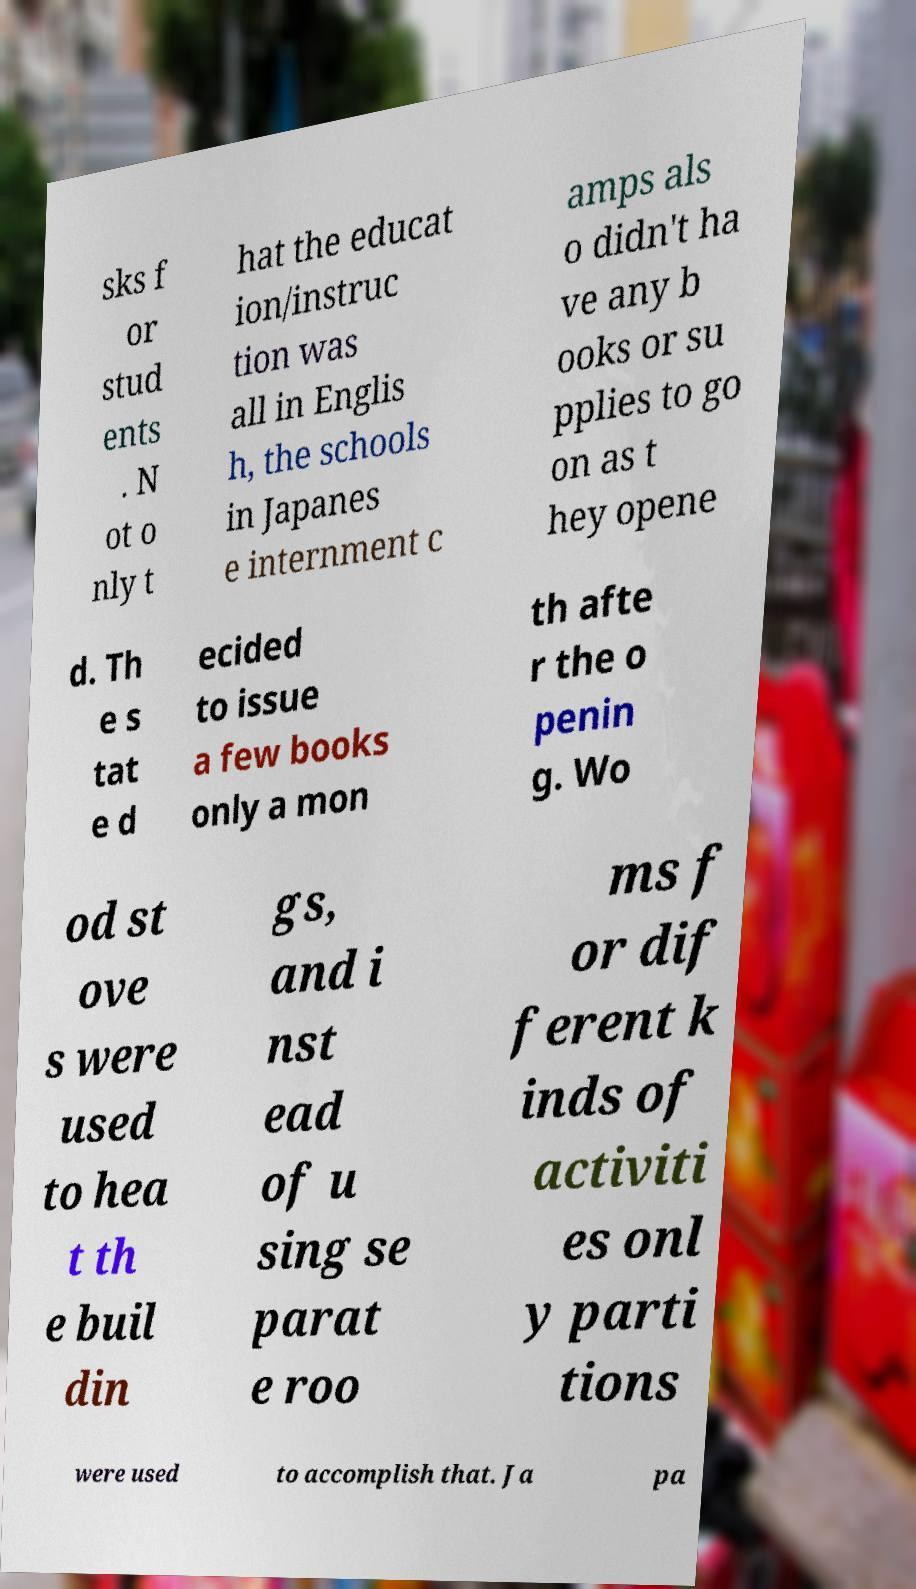Please read and relay the text visible in this image. What does it say? sks f or stud ents . N ot o nly t hat the educat ion/instruc tion was all in Englis h, the schools in Japanes e internment c amps als o didn't ha ve any b ooks or su pplies to go on as t hey opene d. Th e s tat e d ecided to issue a few books only a mon th afte r the o penin g. Wo od st ove s were used to hea t th e buil din gs, and i nst ead of u sing se parat e roo ms f or dif ferent k inds of activiti es onl y parti tions were used to accomplish that. Ja pa 